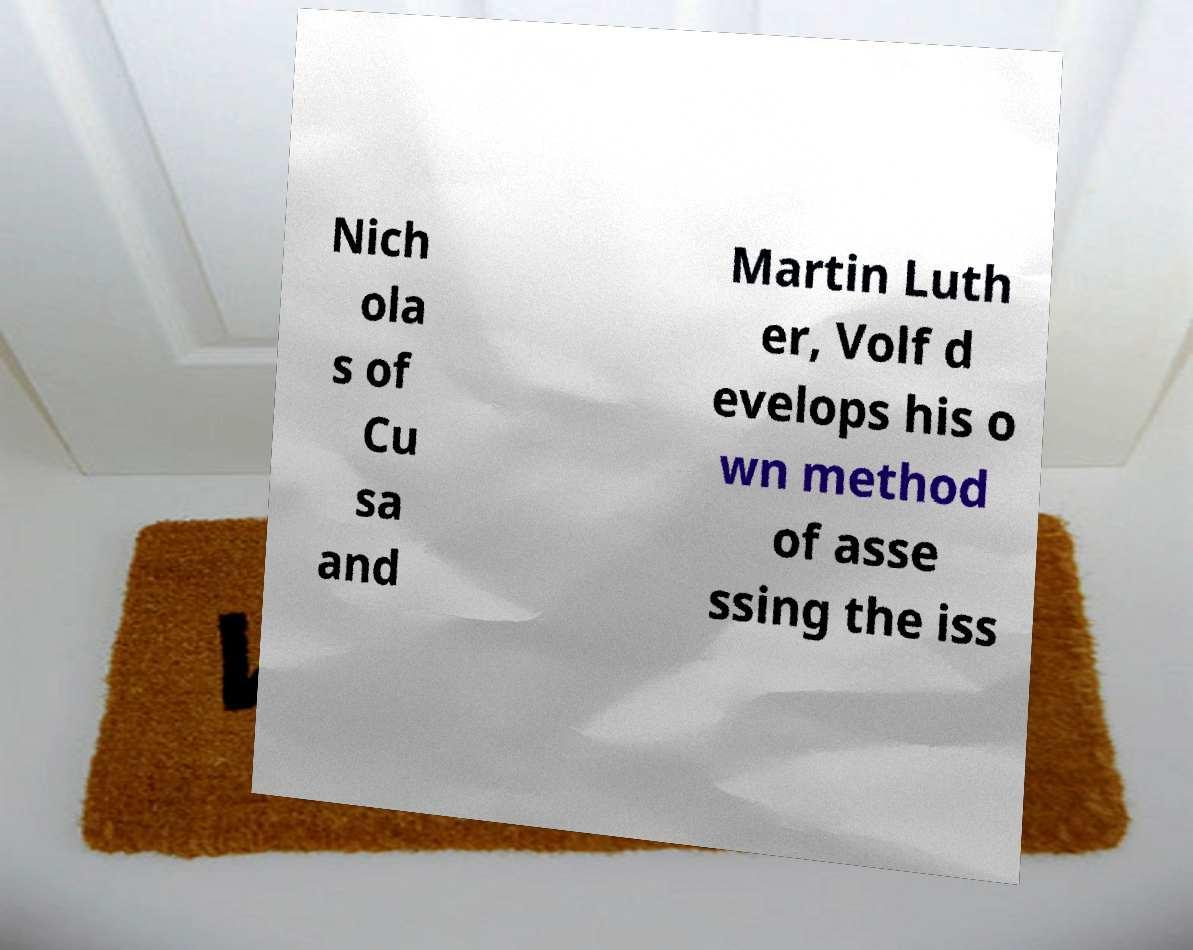For documentation purposes, I need the text within this image transcribed. Could you provide that? Nich ola s of Cu sa and Martin Luth er, Volf d evelops his o wn method of asse ssing the iss 